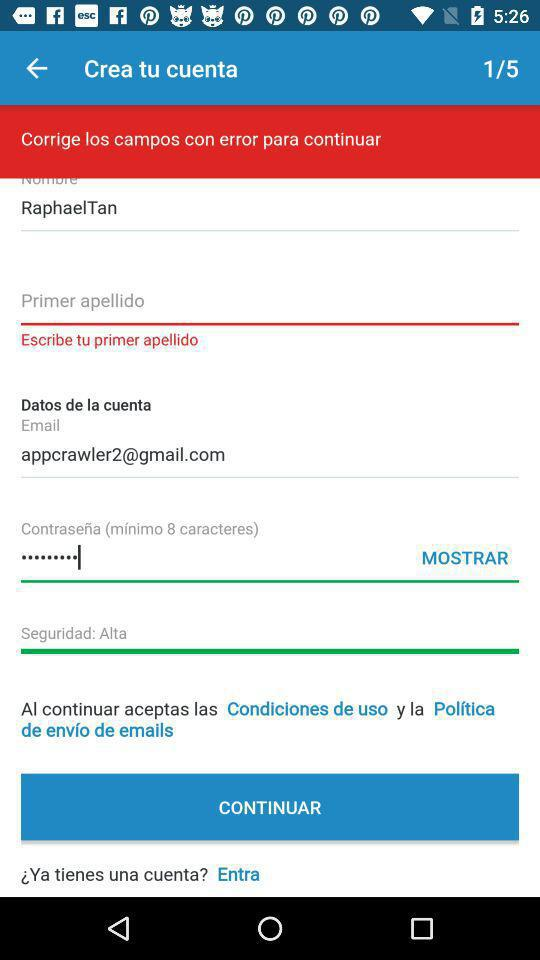What is the given email address? The given email address is appcrawler2@gmail.com. 